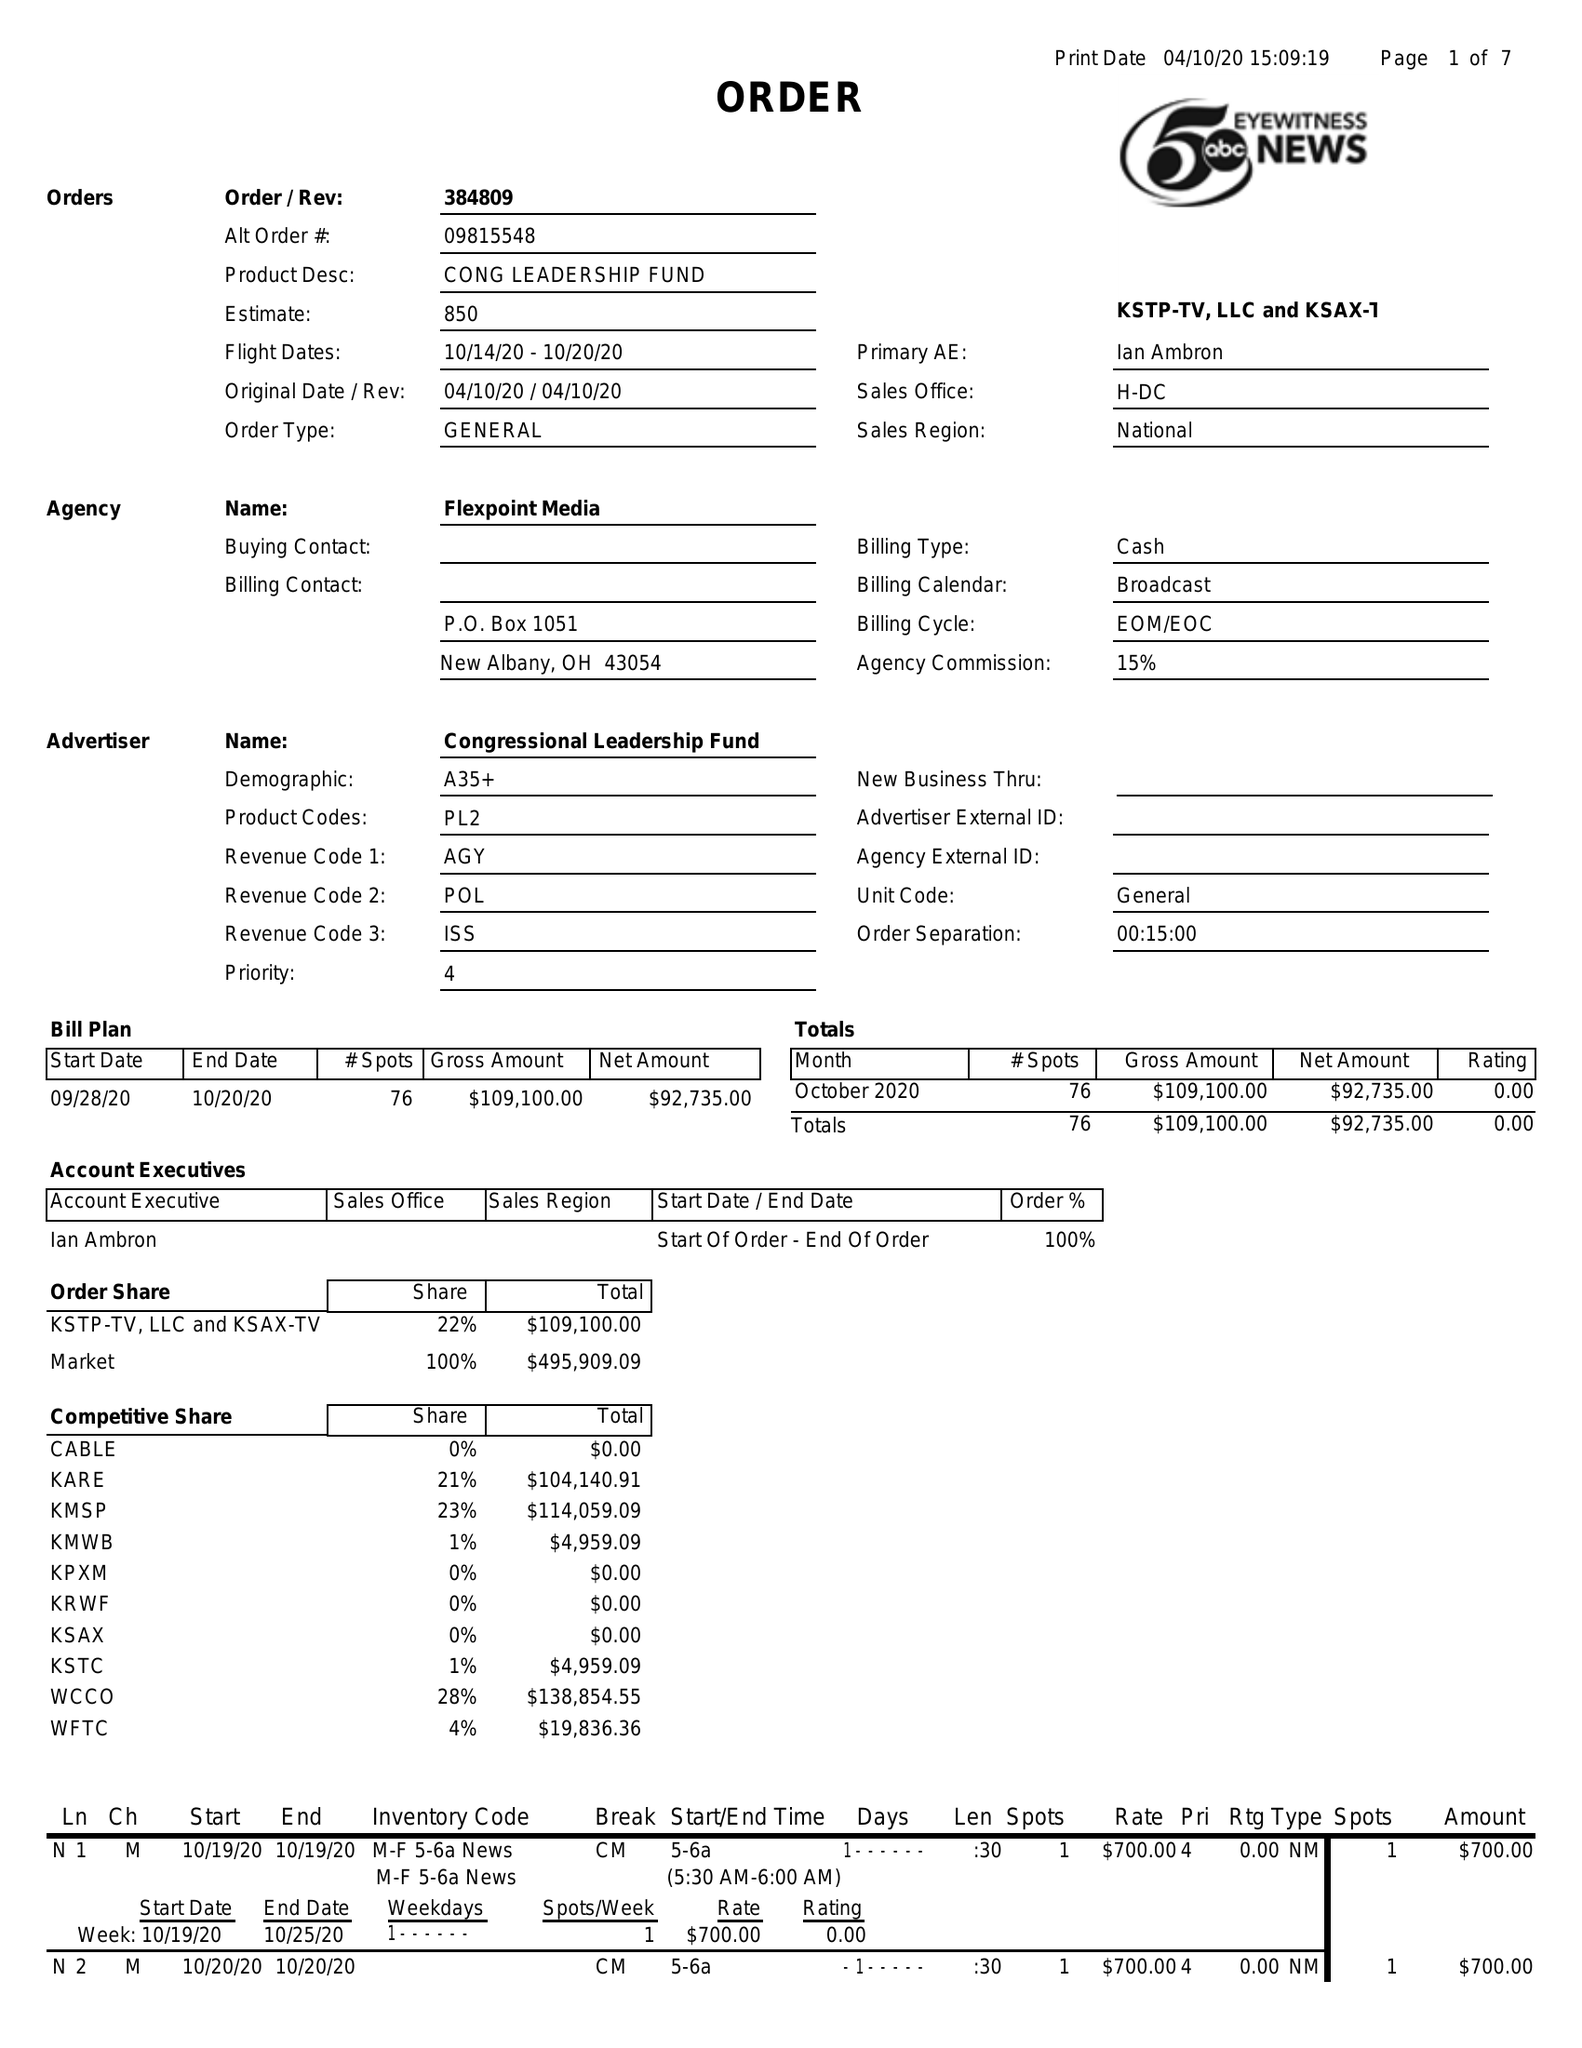What is the value for the advertiser?
Answer the question using a single word or phrase. CONGRESSIONAL LEADERSHIP FUND 